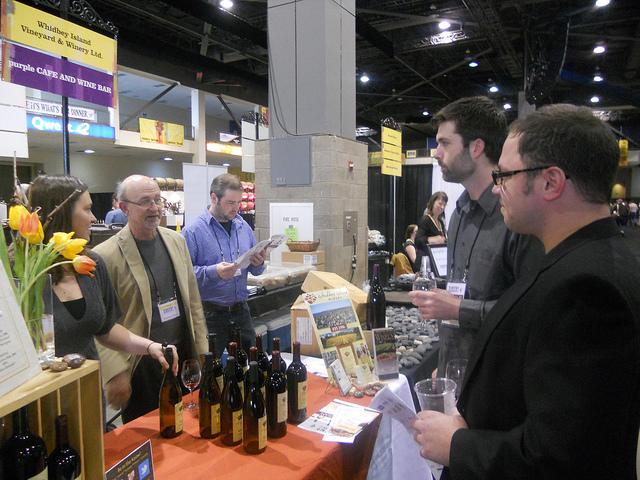Do the tasters appear to enjoy this vintage?
Quick response, please. Yes. Is this a city?
Concise answer only. No. Is this a wine show?
Concise answer only. Yes. IS this outside?
Concise answer only. No. Is the staff on the left or right side of the table?
Quick response, please. Left. 